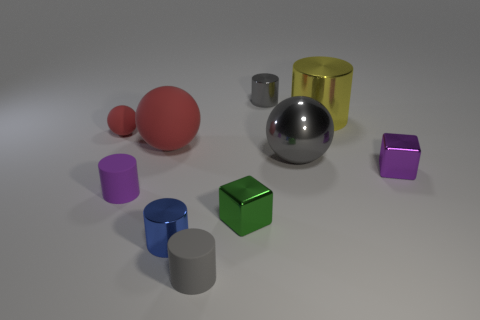Do the small matte ball and the large rubber thing have the same color?
Offer a terse response. Yes. Do the tiny object in front of the tiny blue metal cylinder and the large gray thing have the same shape?
Offer a very short reply. No. How many metal objects are both behind the large yellow cylinder and to the right of the big yellow shiny cylinder?
Ensure brevity in your answer.  0. What is the blue cylinder made of?
Ensure brevity in your answer.  Metal. Are there any other things that have the same color as the tiny rubber sphere?
Offer a terse response. Yes. Is the small green cube made of the same material as the tiny blue cylinder?
Make the answer very short. Yes. How many red rubber balls are on the right side of the tiny purple object that is to the left of the gray shiny object behind the big yellow cylinder?
Offer a very short reply. 1. How many tiny brown rubber blocks are there?
Provide a succinct answer. 0. Are there fewer purple things behind the large gray shiny object than large yellow metallic objects that are on the right side of the big yellow metal cylinder?
Keep it short and to the point. No. Are there fewer metallic cylinders in front of the large yellow shiny cylinder than gray matte blocks?
Offer a very short reply. No. 